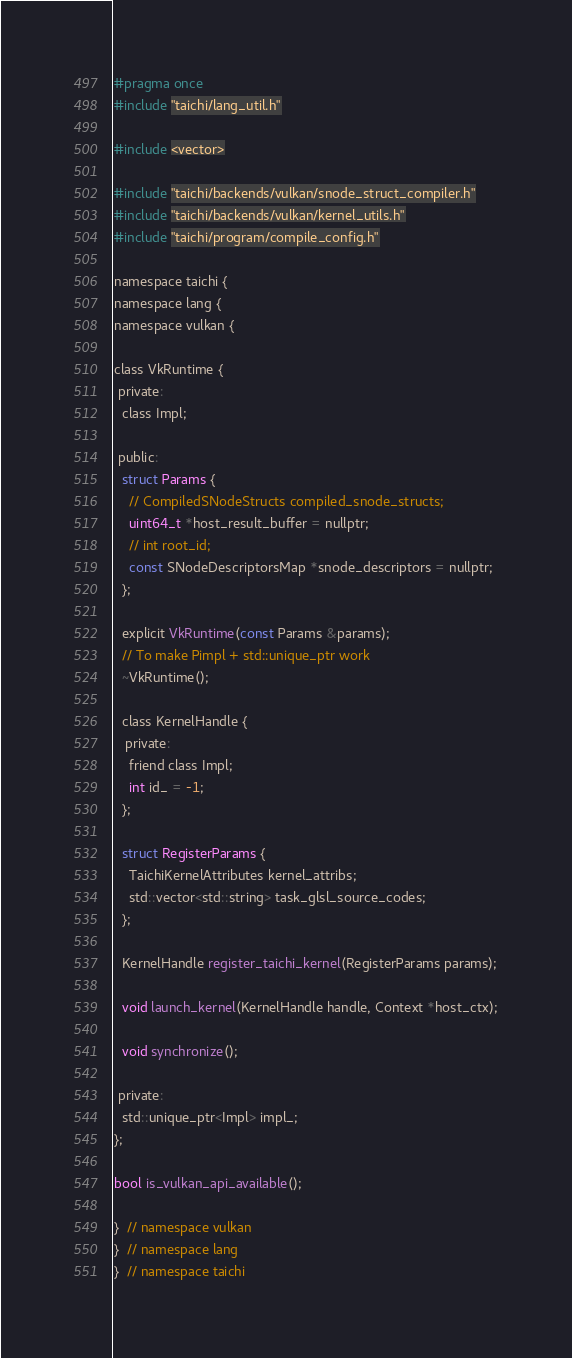Convert code to text. <code><loc_0><loc_0><loc_500><loc_500><_C_>#pragma once
#include "taichi/lang_util.h"

#include <vector>

#include "taichi/backends/vulkan/snode_struct_compiler.h"
#include "taichi/backends/vulkan/kernel_utils.h"
#include "taichi/program/compile_config.h"

namespace taichi {
namespace lang {
namespace vulkan {

class VkRuntime {
 private:
  class Impl;

 public:
  struct Params {
    // CompiledSNodeStructs compiled_snode_structs;
    uint64_t *host_result_buffer = nullptr;
    // int root_id;
    const SNodeDescriptorsMap *snode_descriptors = nullptr;
  };

  explicit VkRuntime(const Params &params);
  // To make Pimpl + std::unique_ptr work
  ~VkRuntime();

  class KernelHandle {
   private:
    friend class Impl;
    int id_ = -1;
  };

  struct RegisterParams {
    TaichiKernelAttributes kernel_attribs;
    std::vector<std::string> task_glsl_source_codes;
  };

  KernelHandle register_taichi_kernel(RegisterParams params);

  void launch_kernel(KernelHandle handle, Context *host_ctx);

  void synchronize();

 private:
  std::unique_ptr<Impl> impl_;
};

bool is_vulkan_api_available();

}  // namespace vulkan
}  // namespace lang
}  // namespace taichi
</code> 